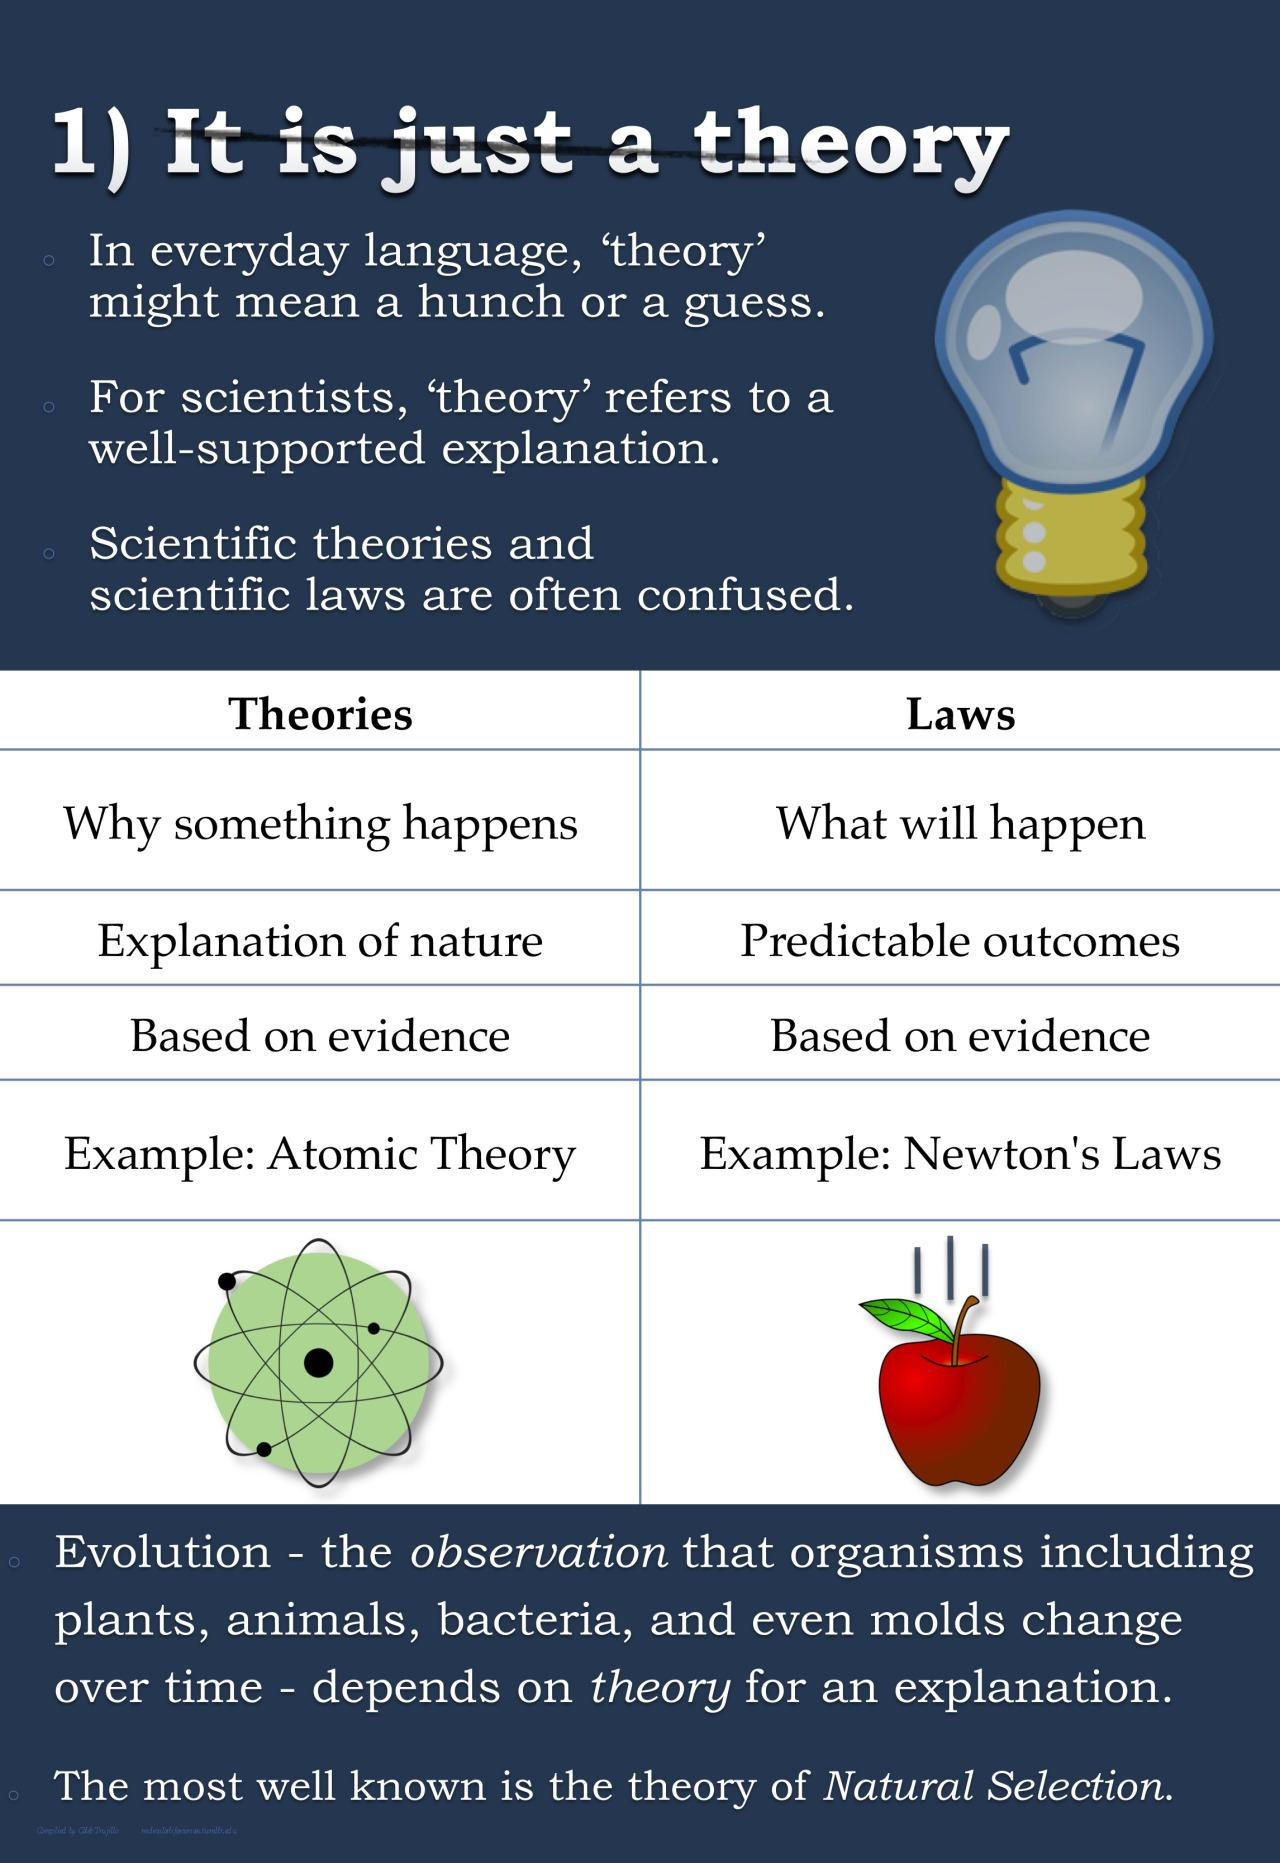Point out several critical features in this image. There are two theories mentioned in this infographic. 